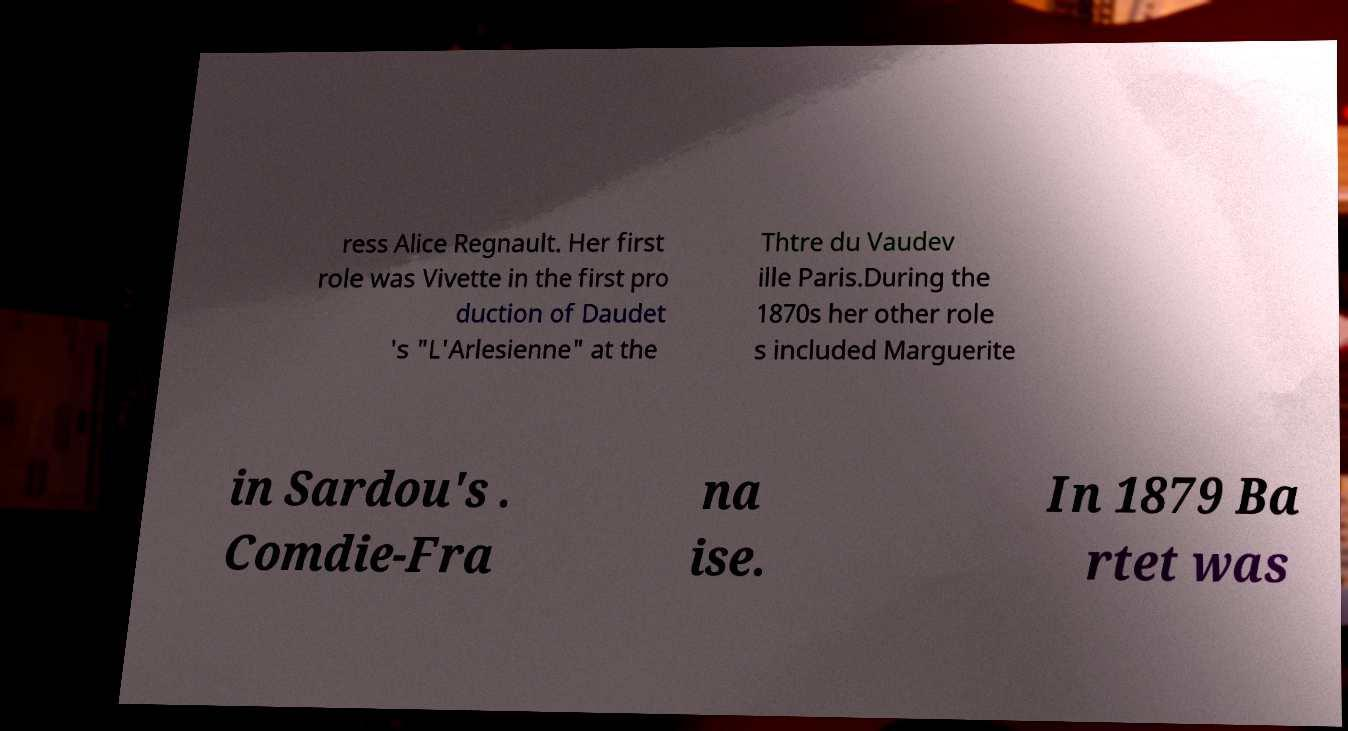Could you extract and type out the text from this image? ress Alice Regnault. Her first role was Vivette in the first pro duction of Daudet 's "L'Arlesienne" at the Thtre du Vaudev ille Paris.During the 1870s her other role s included Marguerite in Sardou's . Comdie-Fra na ise. In 1879 Ba rtet was 